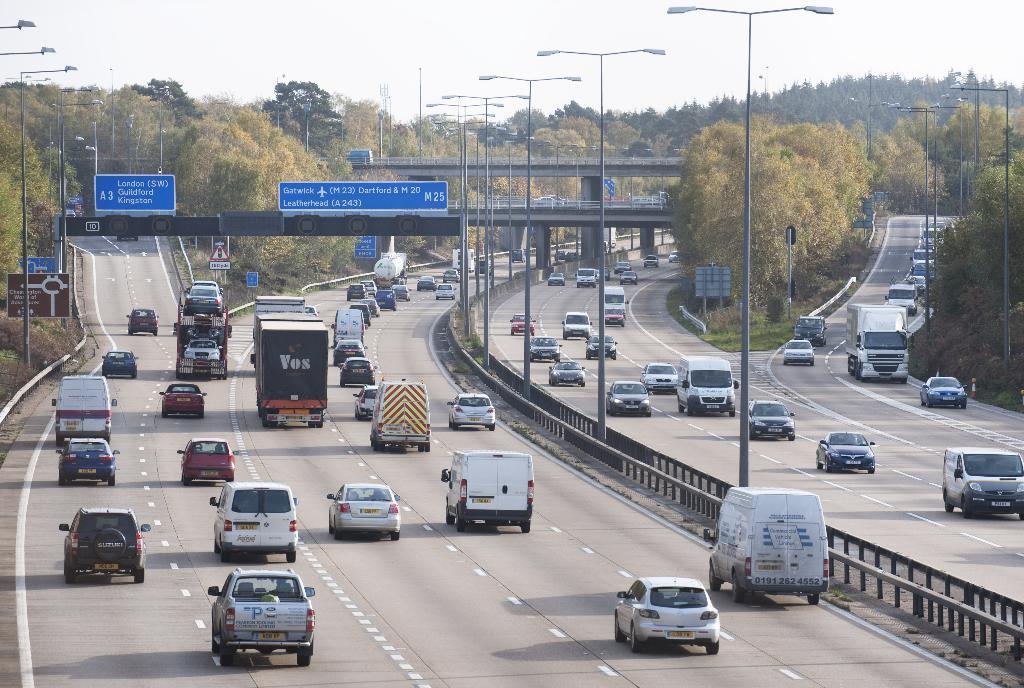Describe this image in one or two sentences. In this picture we can see the sky, trees, bridge. We can see vehicles on the road, lights, poles, blue color boards and other boards. There is a railing in the middle of the road. 